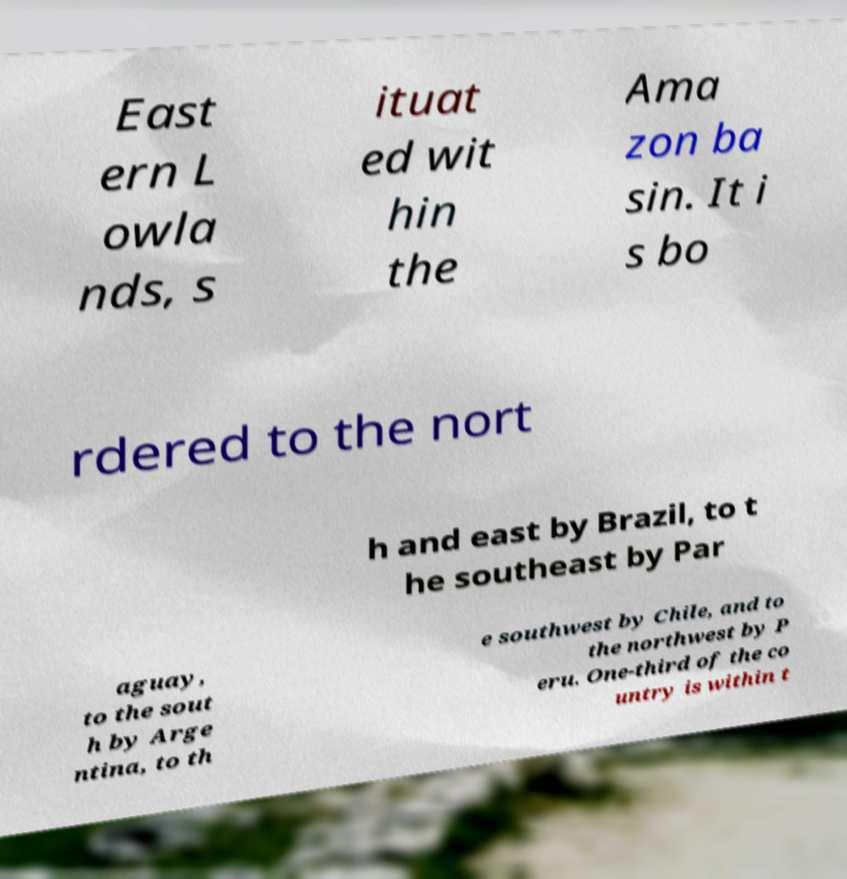I need the written content from this picture converted into text. Can you do that? East ern L owla nds, s ituat ed wit hin the Ama zon ba sin. It i s bo rdered to the nort h and east by Brazil, to t he southeast by Par aguay, to the sout h by Arge ntina, to th e southwest by Chile, and to the northwest by P eru. One-third of the co untry is within t 